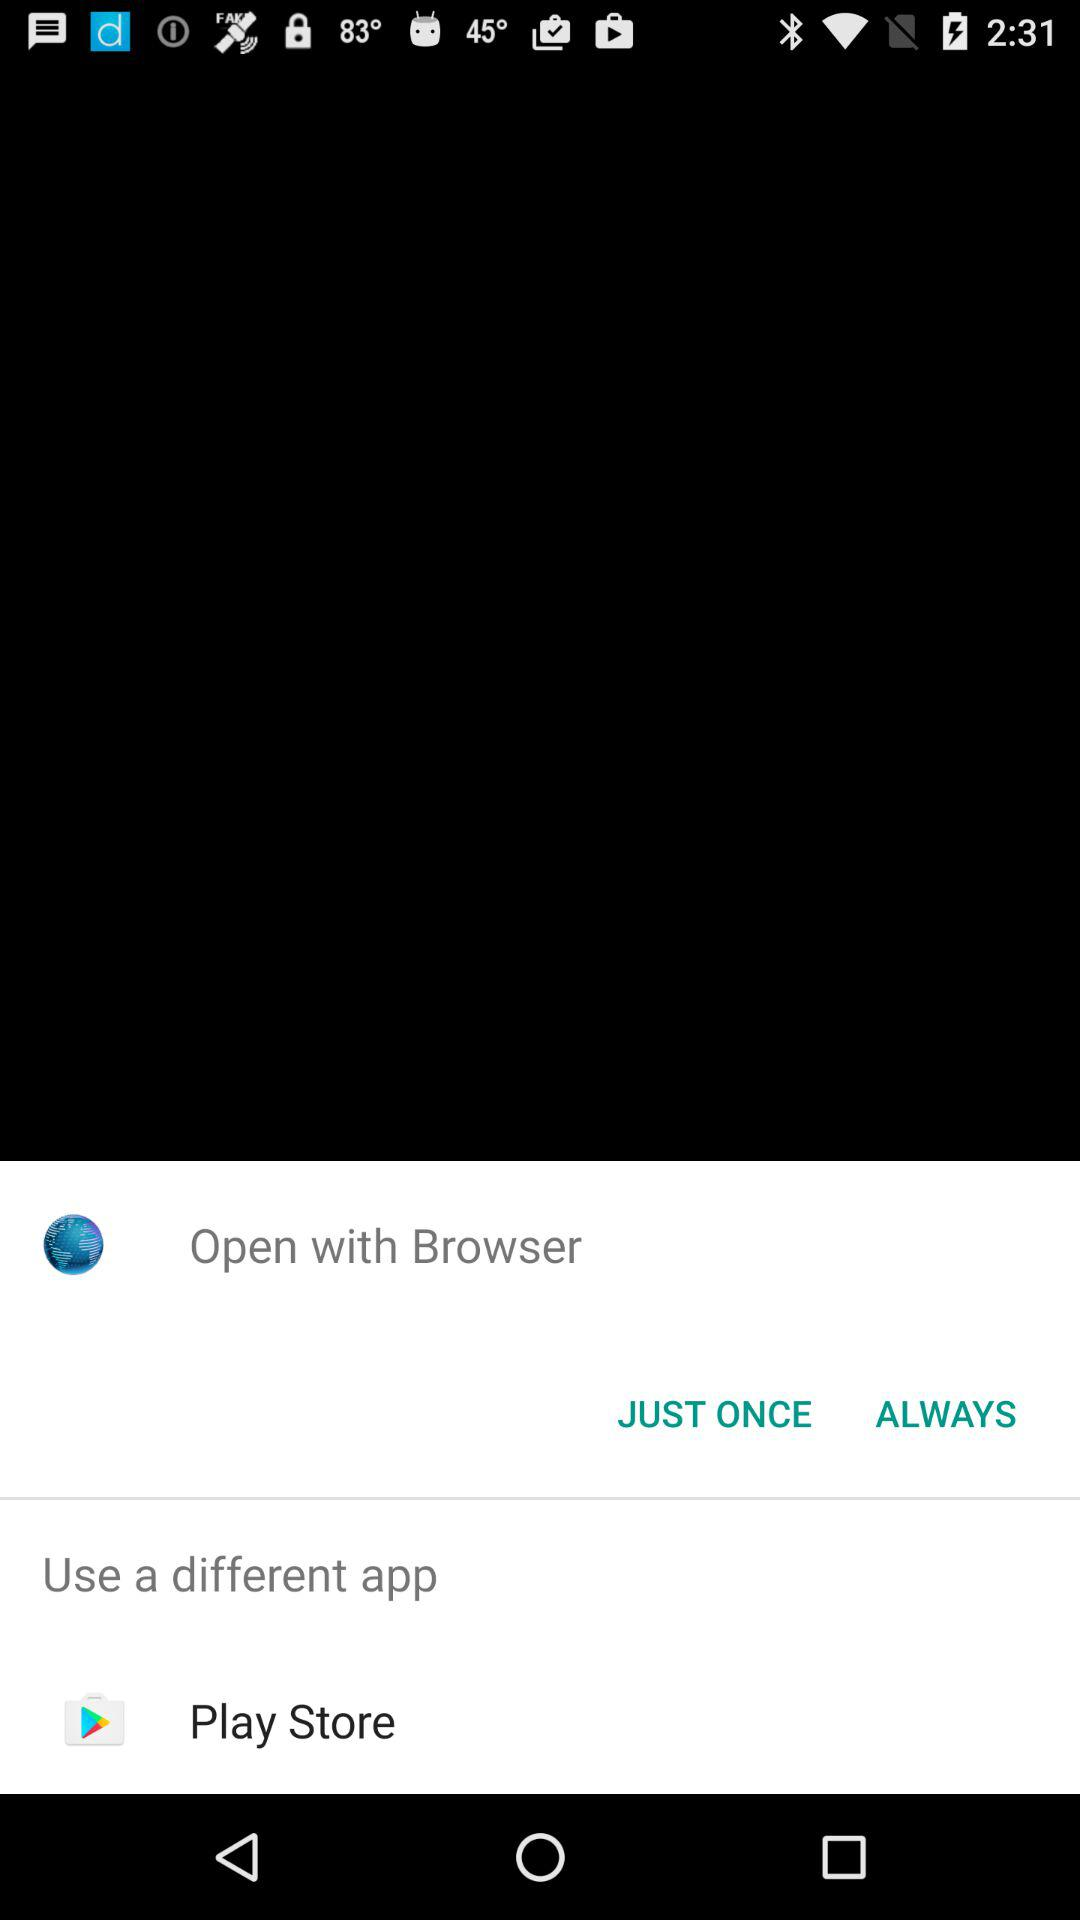Which app is selected to open the content?
When the provided information is insufficient, respond with <no answer>. <no answer> 